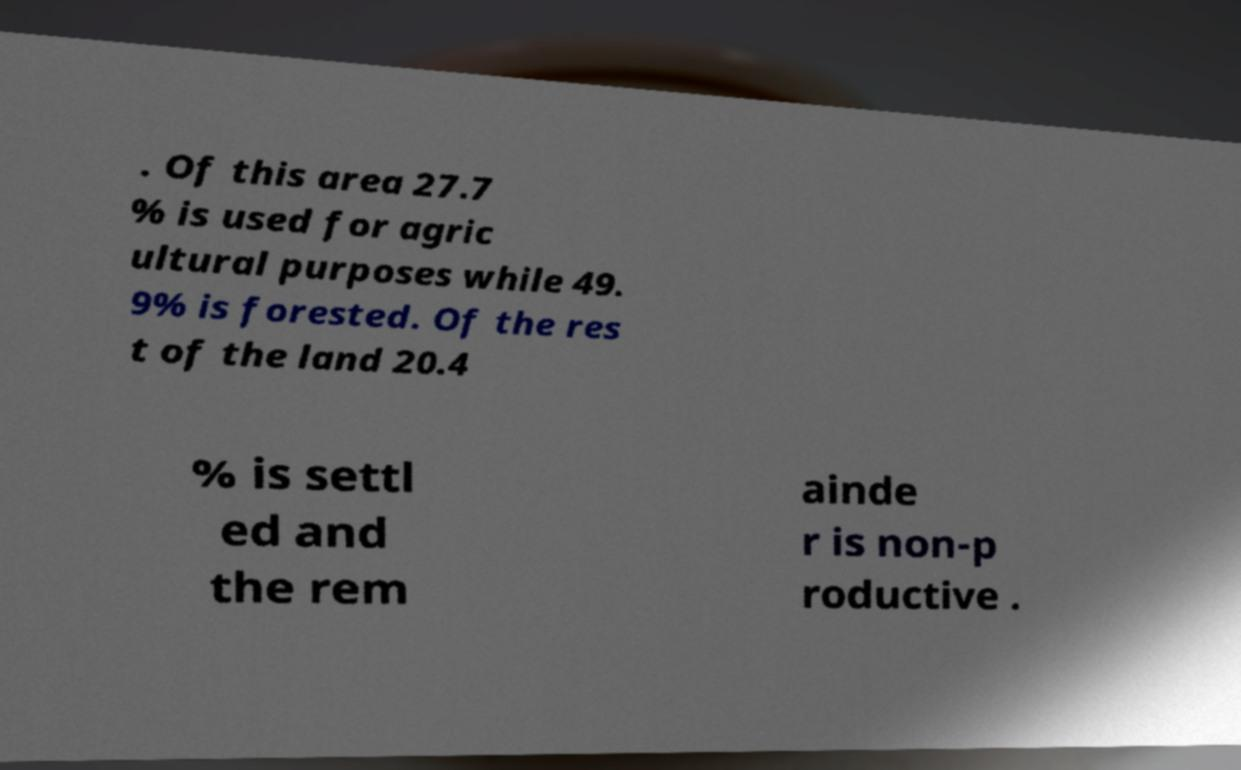Please identify and transcribe the text found in this image. . Of this area 27.7 % is used for agric ultural purposes while 49. 9% is forested. Of the res t of the land 20.4 % is settl ed and the rem ainde r is non-p roductive . 